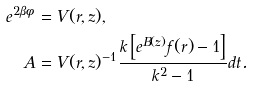Convert formula to latex. <formula><loc_0><loc_0><loc_500><loc_500>e ^ { 2 \beta \phi } & = V ( r , z ) , \\ A & = V ( r , z ) ^ { - 1 } \frac { k \left [ e ^ { B ( z ) } f ( r ) - 1 \right ] } { k ^ { 2 } - 1 } d t .</formula> 